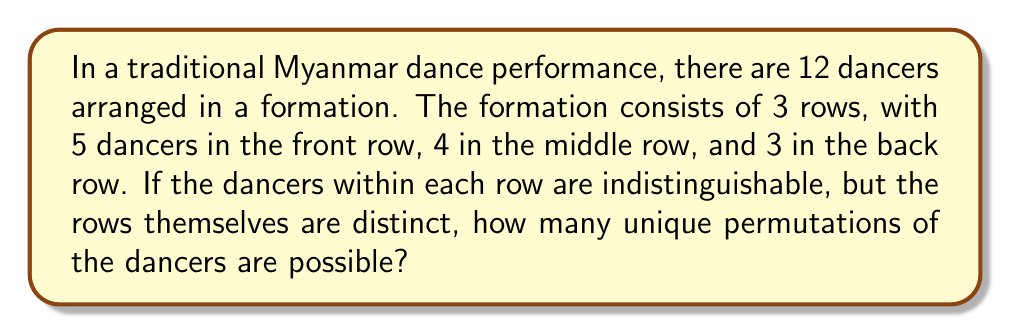Give your solution to this math problem. To solve this problem, we need to use the concept of permutations with indistinguishable objects. Let's approach this step-by-step:

1) First, we need to understand that we are arranging 12 dancers in total.

2) The dancers are divided into three distinct rows:
   - Front row: 5 dancers
   - Middle row: 4 dancers
   - Back row: 3 dancers

3) Within each row, the dancers are considered indistinguishable. This means that rearranging dancers within a row doesn't create a new permutation.

4) The number of ways to arrange n indistinguishable objects is 1.

5) Therefore, we need to calculate the number of ways to choose which 5 dancers go in the front row, which 4 go in the middle row, and which 3 go in the back row.

6) This is equivalent to choosing 5 dancers out of 12 for the front row, then 4 out of the remaining 7 for the middle row, and the last 3 automatically go to the back row.

7) We can calculate this using the combination formula:

   $$\binom{12}{5} \cdot \binom{7}{4}$$

8) Let's calculate each part:

   $$\binom{12}{5} = \frac{12!}{5!(12-5)!} = \frac{12!}{5!7!} = 792$$

   $$\binom{7}{4} = \frac{7!}{4!(7-4)!} = \frac{7!}{4!3!} = 35$$

9) Now, we multiply these results:

   $$792 \cdot 35 = 27,720$$

Therefore, there are 27,720 unique permutations possible.
Answer: 27,720 